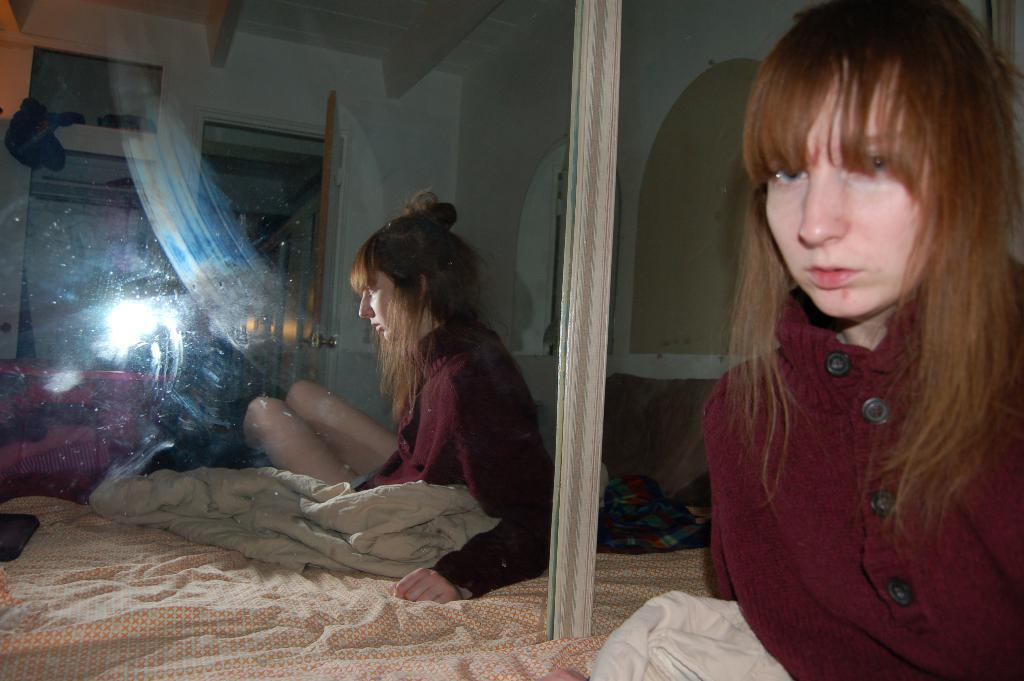What is the woman in the image wearing? The woman in the image is wearing a red jacket. How is the woman in the image being emphasized? The woman is highlighted in the image. What object in the image allows for reflection? There is a mirror in the image. Who or what is reflected in the mirror? The mirror reflects the woman. What piece of furniture is present in the image? There is a bed with a bed-sheet in the image. How many sheep are visible in the image? There are no sheep present in the image. What type of plastic material can be seen in the image? There is no plastic material visible in the image. 